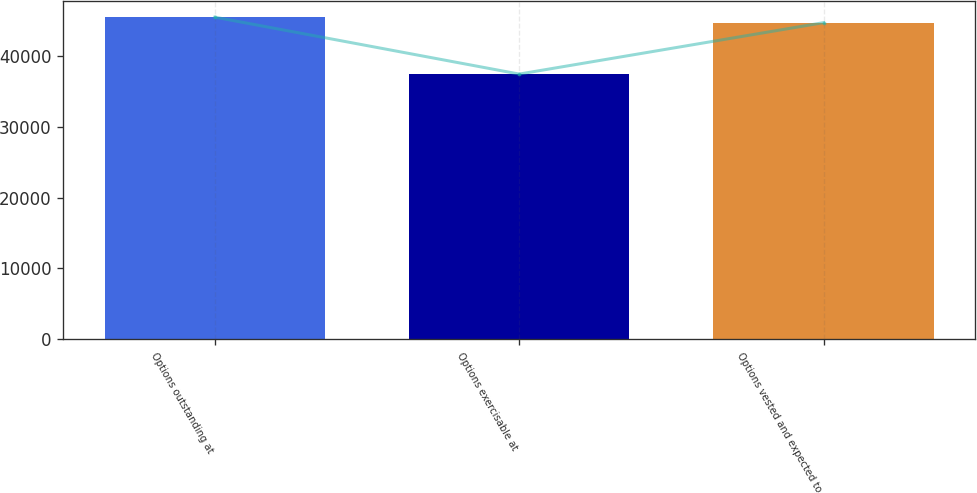Convert chart to OTSL. <chart><loc_0><loc_0><loc_500><loc_500><bar_chart><fcel>Options outstanding at<fcel>Options exercisable at<fcel>Options vested and expected to<nl><fcel>45496.6<fcel>37452<fcel>44720<nl></chart> 